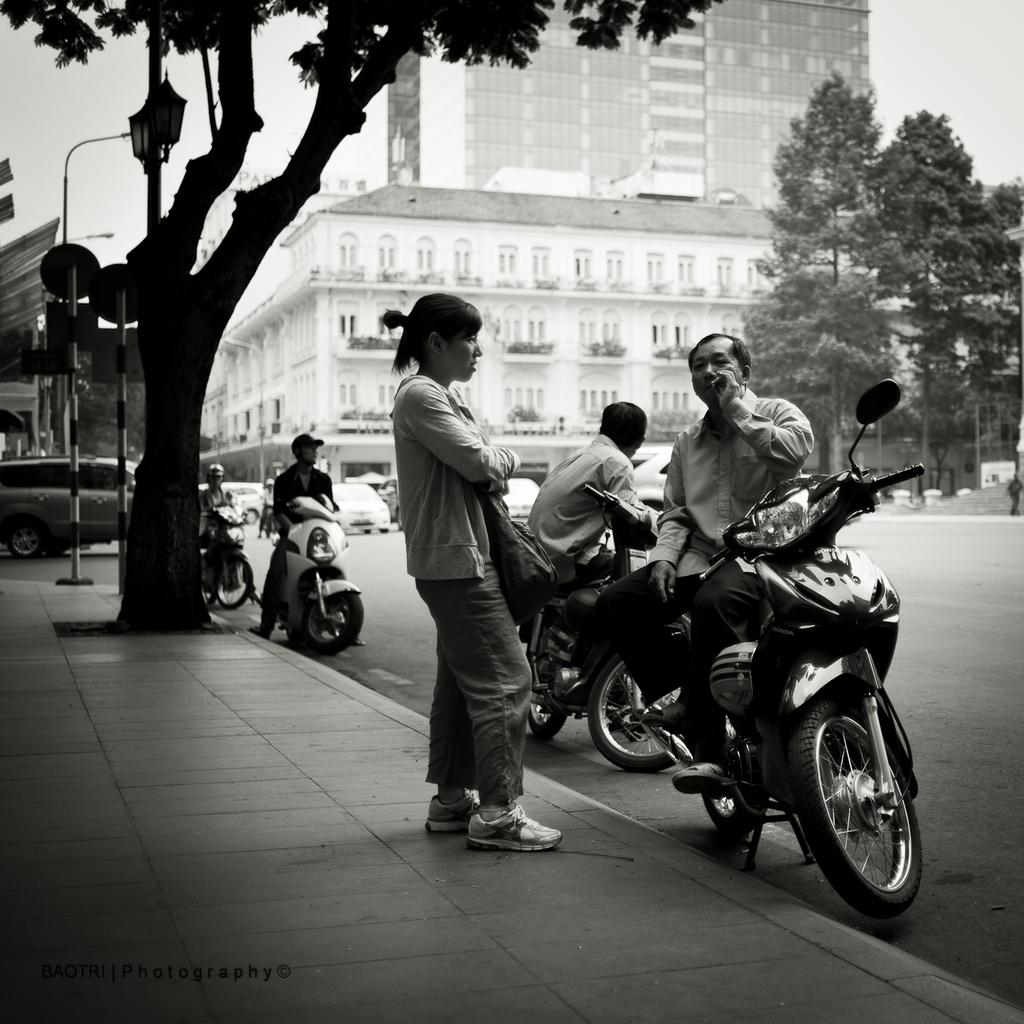What type of structures can be seen in the image? There are buildings in the image. What other natural elements are present in the image? There are trees in the image. Are there any living beings visible in the image? Yes, there are people in the image. What types of vehicles can be seen in the image? There are cars and motorcycles in the image. Where is the book located in the image? There is no book present in the image. What type of lunch is being served in the image? There is no lunch being served in the image. 